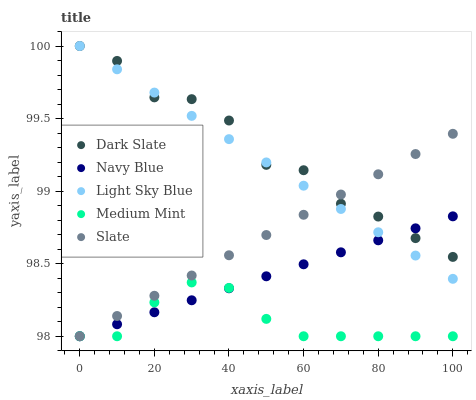Does Medium Mint have the minimum area under the curve?
Answer yes or no. Yes. Does Dark Slate have the maximum area under the curve?
Answer yes or no. Yes. Does Slate have the minimum area under the curve?
Answer yes or no. No. Does Slate have the maximum area under the curve?
Answer yes or no. No. Is Navy Blue the smoothest?
Answer yes or no. Yes. Is Dark Slate the roughest?
Answer yes or no. Yes. Is Slate the smoothest?
Answer yes or no. No. Is Slate the roughest?
Answer yes or no. No. Does Medium Mint have the lowest value?
Answer yes or no. Yes. Does Dark Slate have the lowest value?
Answer yes or no. No. Does Light Sky Blue have the highest value?
Answer yes or no. Yes. Does Slate have the highest value?
Answer yes or no. No. Is Medium Mint less than Light Sky Blue?
Answer yes or no. Yes. Is Light Sky Blue greater than Medium Mint?
Answer yes or no. Yes. Does Medium Mint intersect Slate?
Answer yes or no. Yes. Is Medium Mint less than Slate?
Answer yes or no. No. Is Medium Mint greater than Slate?
Answer yes or no. No. Does Medium Mint intersect Light Sky Blue?
Answer yes or no. No. 